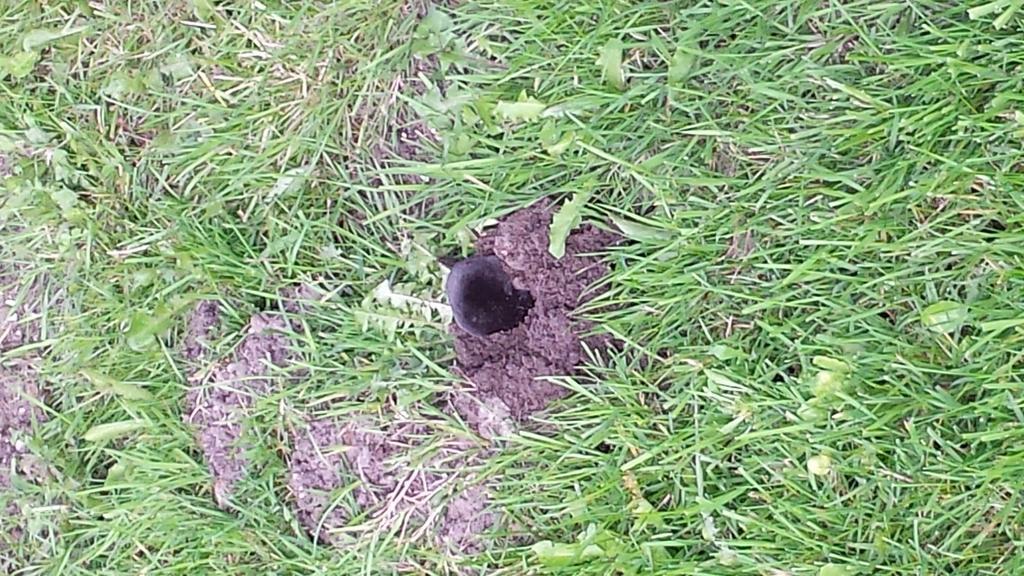How would you summarize this image in a sentence or two? In this picture we can see some grass and a few leaves. There is a black object. 